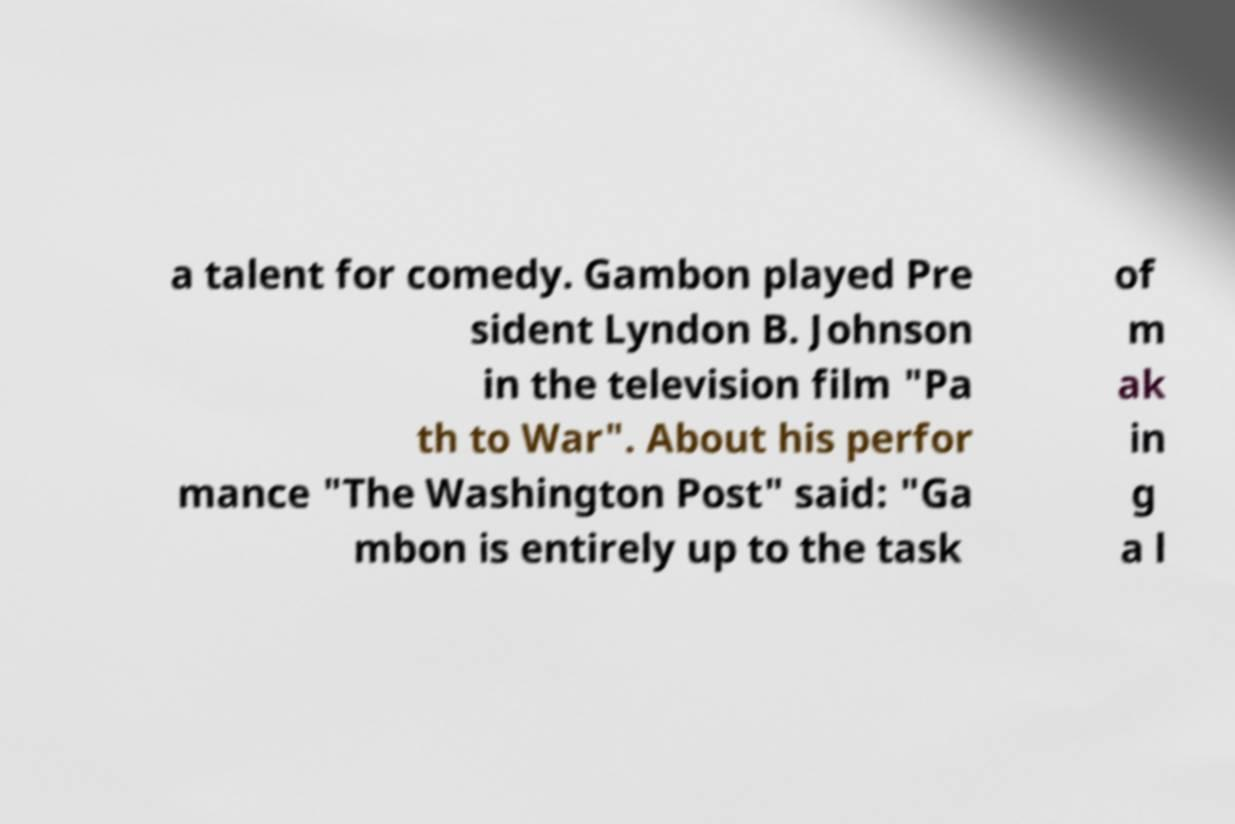I need the written content from this picture converted into text. Can you do that? a talent for comedy. Gambon played Pre sident Lyndon B. Johnson in the television film "Pa th to War". About his perfor mance "The Washington Post" said: "Ga mbon is entirely up to the task of m ak in g a l 